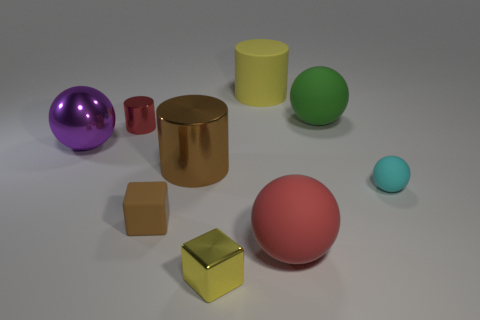There is a tiny metal thing that is left of the small yellow object; are there any red metal things in front of it?
Provide a short and direct response. No. There is another large metallic thing that is the same shape as the cyan thing; what color is it?
Ensure brevity in your answer.  Purple. Is the color of the tiny metal object that is behind the large brown cylinder the same as the tiny rubber sphere?
Provide a succinct answer. No. How many things are either shiny cylinders that are in front of the purple object or large cylinders?
Your response must be concise. 2. What is the material of the red thing in front of the red object that is behind the small rubber object in front of the cyan object?
Offer a very short reply. Rubber. Are there more blocks behind the brown metal cylinder than brown rubber objects in front of the small yellow metallic block?
Offer a very short reply. No. How many blocks are metallic objects or cyan matte things?
Your answer should be very brief. 1. What number of red cylinders are in front of the big shiny object that is on the right side of the tiny metal object that is behind the small yellow metallic object?
Offer a terse response. 0. There is a cylinder that is the same color as the small metallic cube; what is it made of?
Your answer should be very brief. Rubber. Are there more tiny brown rubber cubes than red cubes?
Your answer should be compact. Yes. 